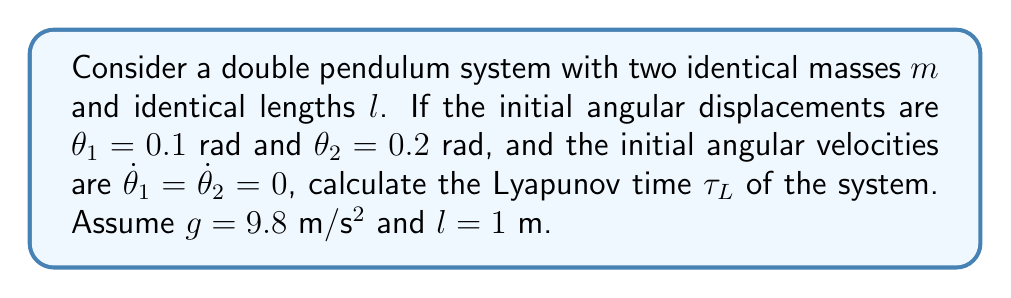Provide a solution to this math problem. To calculate the Lyapunov time for the double pendulum system, we'll follow these steps:

1) The Lyapunov time is defined as $\tau_L = \frac{1}{\lambda}$, where $\lambda$ is the largest Lyapunov exponent.

2) For a double pendulum, the largest Lyapunov exponent can be approximated as:

   $$\lambda \approx \sqrt{\frac{g}{l}}$$

3) Substituting the given values:
   
   $$\lambda \approx \sqrt{\frac{9.8 \text{ m/s²}}{1 \text{ m}}} = \sqrt{9.8} \approx 3.13 \text{ s}^{-1}$$

4) Now we can calculate the Lyapunov time:

   $$\tau_L = \frac{1}{\lambda} \approx \frac{1}{3.13 \text{ s}^{-1}} \approx 0.32 \text{ s}$$

5) This means that after about 0.32 seconds, the predictability of the system's behavior decreases significantly due to its chaotic nature.

It's important to note that while the initial conditions are specified in the question, they don't directly affect the Lyapunov time calculation in this simplified model. However, they would influence the specific trajectory of the system.
Answer: $\tau_L \approx 0.32 \text{ s}$ 